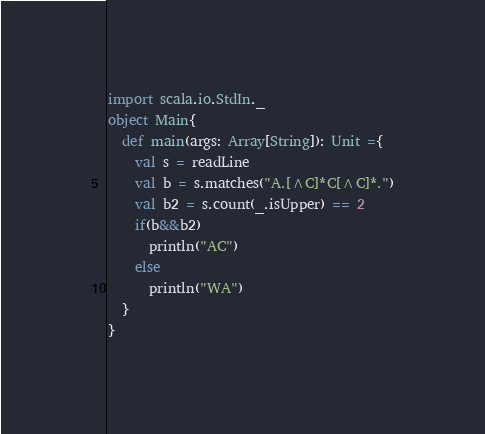Convert code to text. <code><loc_0><loc_0><loc_500><loc_500><_Scala_>import scala.io.StdIn._
object Main{
  def main(args: Array[String]): Unit ={
    val s = readLine
    val b = s.matches("A.[^C]*C[^C]*.")
    val b2 = s.count(_.isUpper) == 2
    if(b&&b2)
      println("AC")
    else
      println("WA")
  }
}
</code> 